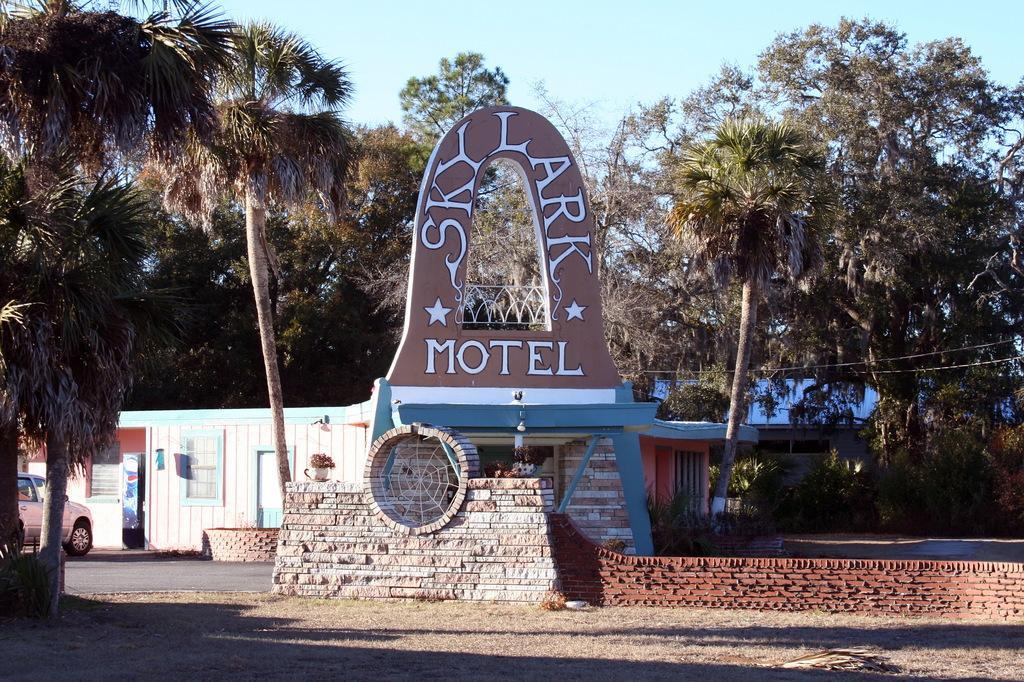In one or two sentences, can you explain what this image depicts? In the image we can see a house and a poster, on it there is a text. We can even see there is a vehicle and a stone wall. There are even trees, dry grass and the sky. 